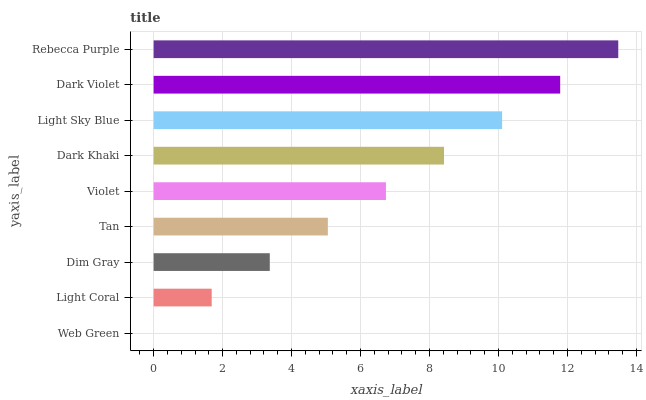Is Web Green the minimum?
Answer yes or no. Yes. Is Rebecca Purple the maximum?
Answer yes or no. Yes. Is Light Coral the minimum?
Answer yes or no. No. Is Light Coral the maximum?
Answer yes or no. No. Is Light Coral greater than Web Green?
Answer yes or no. Yes. Is Web Green less than Light Coral?
Answer yes or no. Yes. Is Web Green greater than Light Coral?
Answer yes or no. No. Is Light Coral less than Web Green?
Answer yes or no. No. Is Violet the high median?
Answer yes or no. Yes. Is Violet the low median?
Answer yes or no. Yes. Is Rebecca Purple the high median?
Answer yes or no. No. Is Tan the low median?
Answer yes or no. No. 